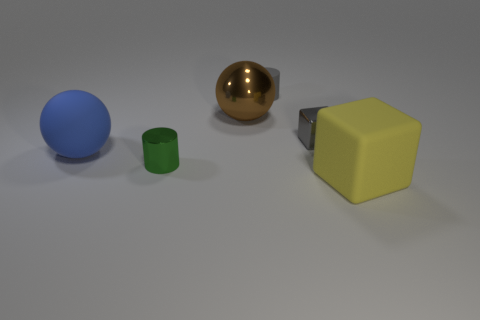Add 1 small green blocks. How many objects exist? 7 Subtract all spheres. How many objects are left? 4 Subtract 0 gray balls. How many objects are left? 6 Subtract all large brown balls. Subtract all spheres. How many objects are left? 3 Add 5 yellow things. How many yellow things are left? 6 Add 4 blue things. How many blue things exist? 5 